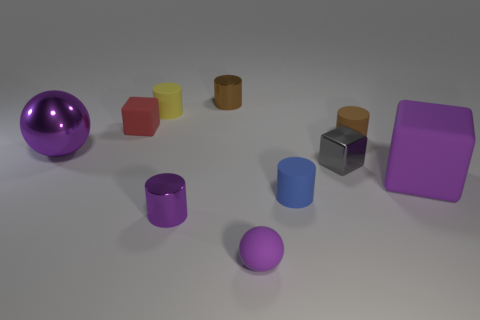What color is the thing that is both in front of the tiny gray thing and behind the blue thing?
Provide a short and direct response. Purple. How many purple matte cubes are the same size as the red matte object?
Provide a succinct answer. 0. The purple metal object to the right of the purple ball on the left side of the small red rubber block is what shape?
Provide a short and direct response. Cylinder. What is the shape of the small metallic object to the right of the purple ball that is right of the purple metallic object that is in front of the big purple block?
Offer a terse response. Cube. What number of large purple rubber things are the same shape as the small purple shiny object?
Offer a very short reply. 0. How many tiny things are in front of the small metallic object that is to the left of the brown shiny cylinder?
Offer a terse response. 1. How many shiny things are tiny brown cylinders or tiny red objects?
Provide a short and direct response. 1. Is there a large red sphere made of the same material as the small blue cylinder?
Ensure brevity in your answer.  No. How many objects are either tiny rubber things in front of the large cube or small cylinders that are in front of the red rubber cube?
Offer a very short reply. 4. Is the color of the thing that is on the right side of the tiny brown matte cylinder the same as the large shiny thing?
Your answer should be compact. Yes. 